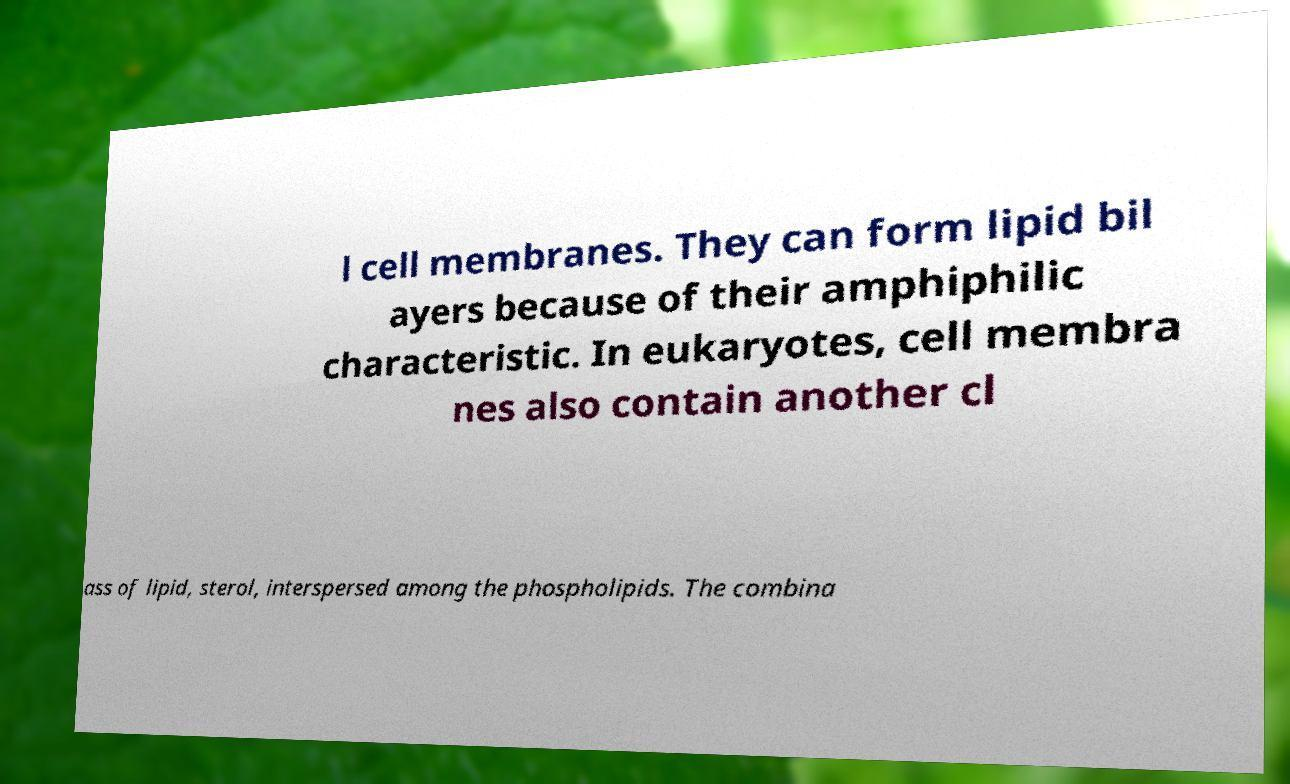There's text embedded in this image that I need extracted. Can you transcribe it verbatim? l cell membranes. They can form lipid bil ayers because of their amphiphilic characteristic. In eukaryotes, cell membra nes also contain another cl ass of lipid, sterol, interspersed among the phospholipids. The combina 